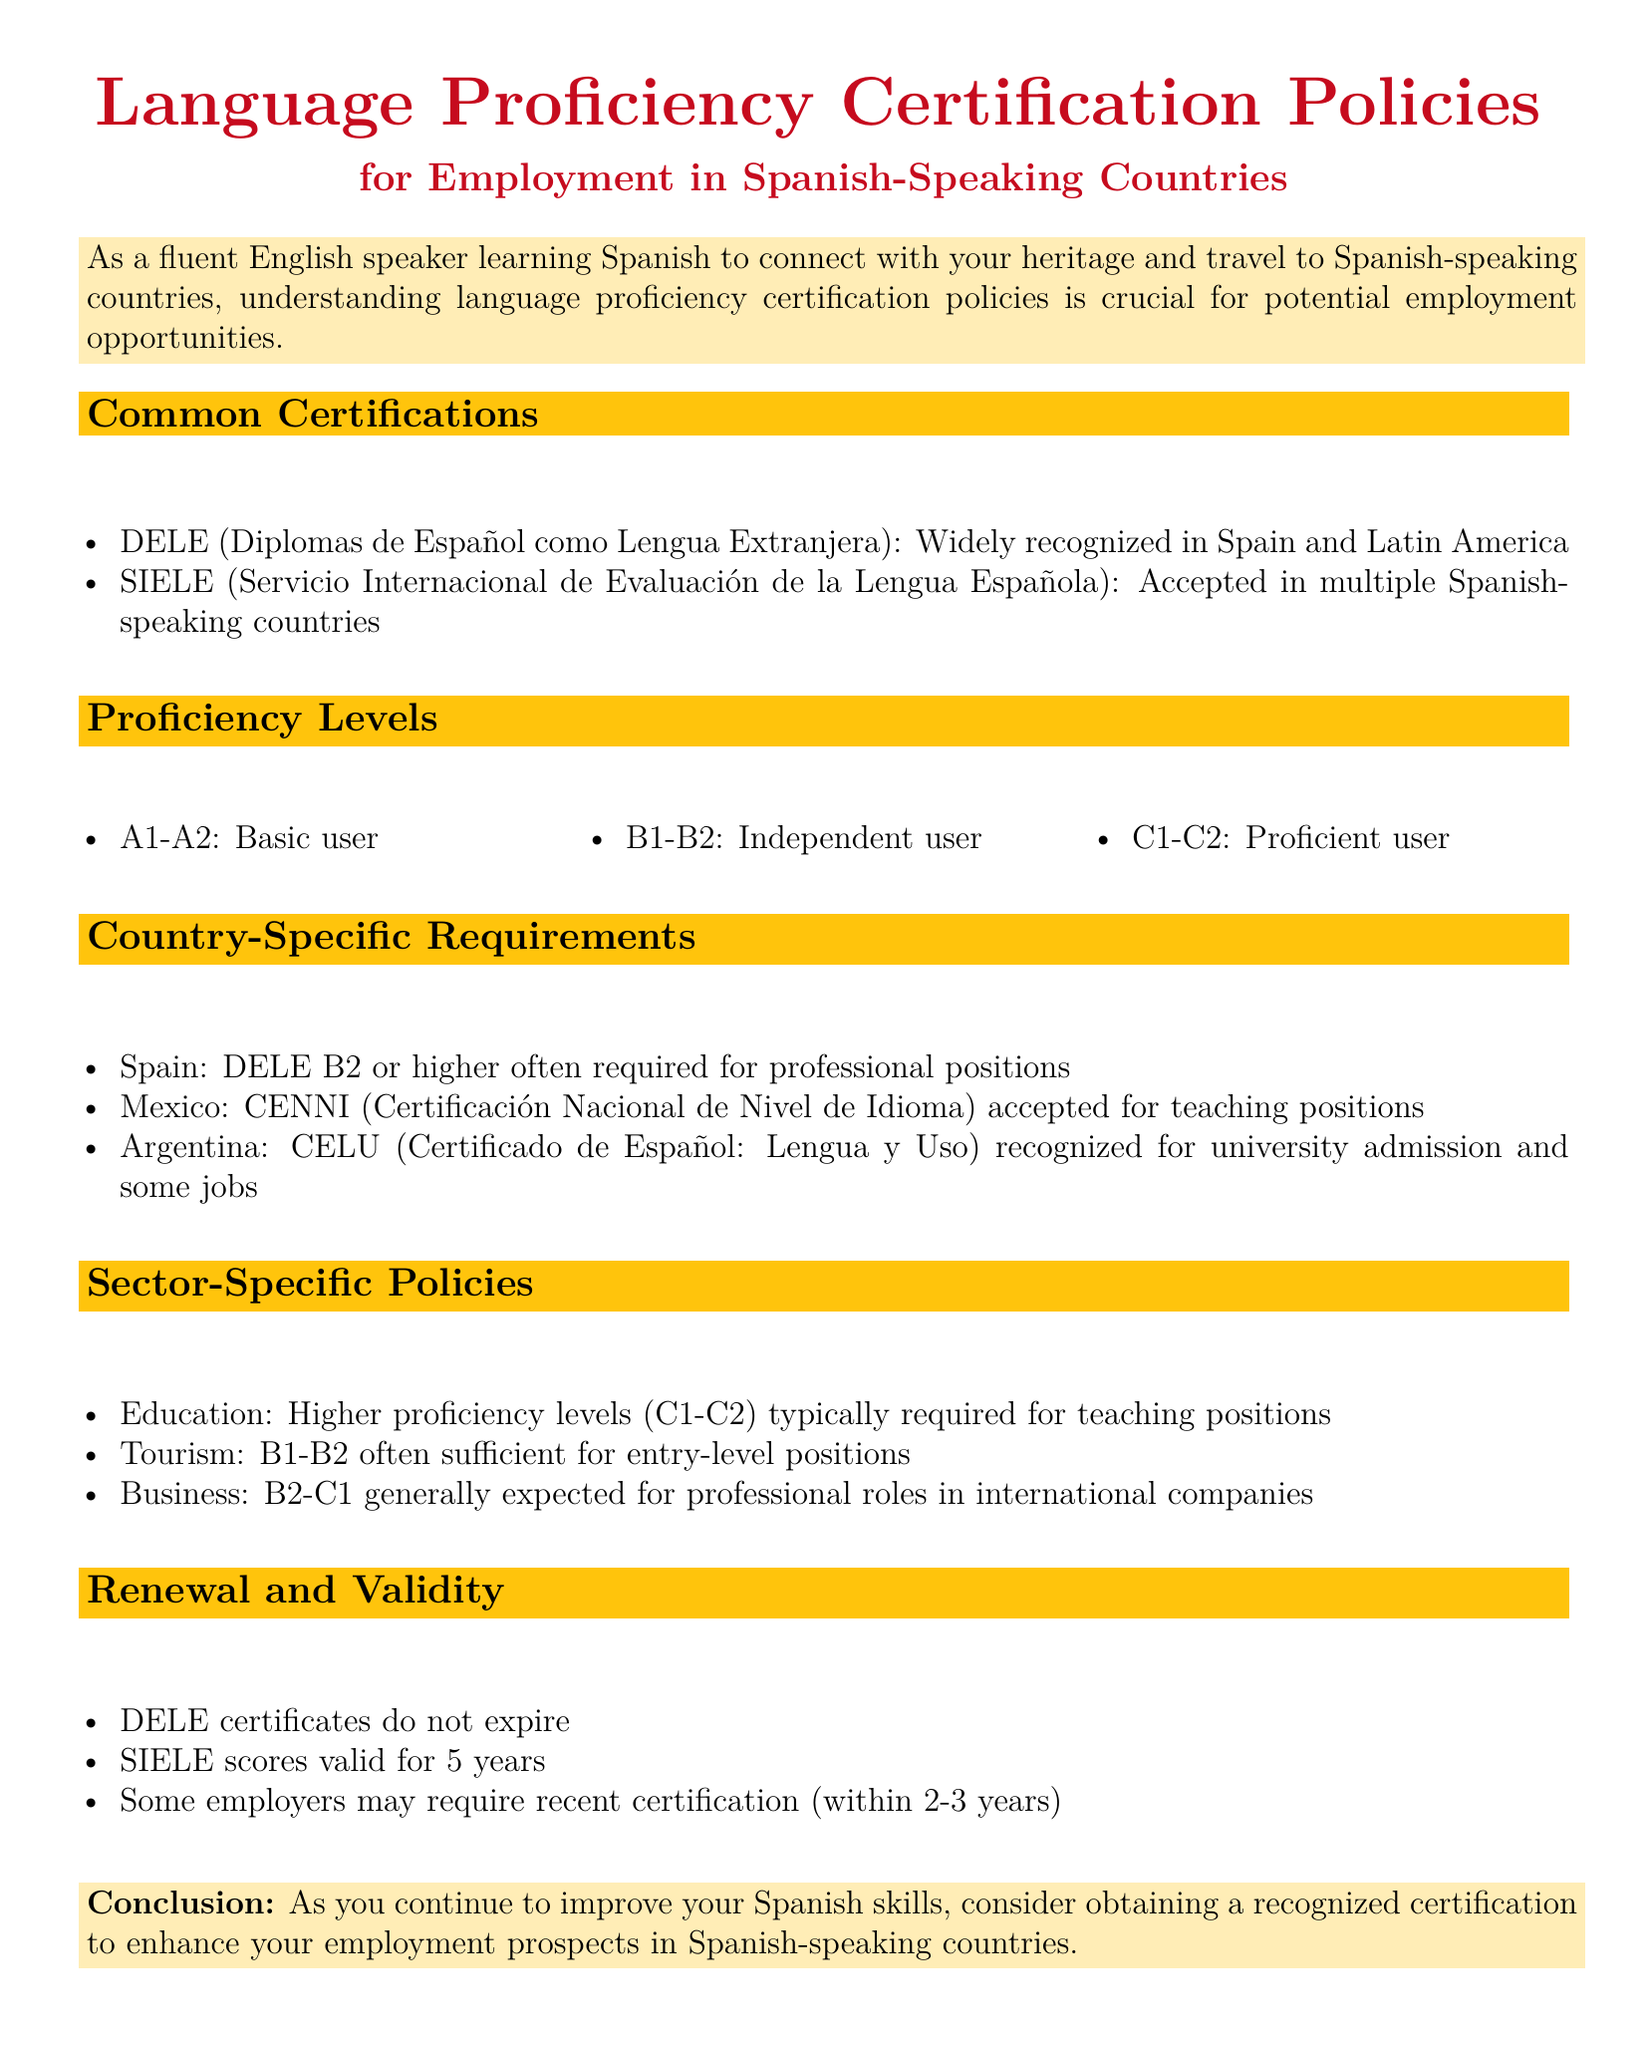What does DELE stand for? DELE stands for "Diplomas de Español como Lengua Extranjera," which is mentioned as a widely recognized certification.
Answer: Diplomas de Español como Lengua Extranjera What is the validity period of SIELE scores? The validity period of SIELE scores is specified in the document as 5 years.
Answer: 5 years Which proficiency level is associated with basic user? The document lists the proficiency levels, and A1-A2 is designated for basic users.
Answer: A1-A2 What certification is accepted for teaching positions in Mexico? The certification mentioned for teaching positions in Mexico is CENNI.
Answer: CENNI What proficiency levels are generally expected in business roles? According to the sector-specific policies, B2-C1 proficiency levels are generally expected for professional roles in business.
Answer: B2-C1 Does the DELE certificate expire? The document states that DELE certificates do not expire, indicating their long-term validity.
Answer: No What is the recognition of CELU in Argentina? CELU is recognized for university admission and some jobs in Argentina.
Answer: University admission and some jobs Which level is often required for professional positions in Spain? The required level for professional positions in Spain is B2 or higher as per the document.
Answer: B2 or higher 